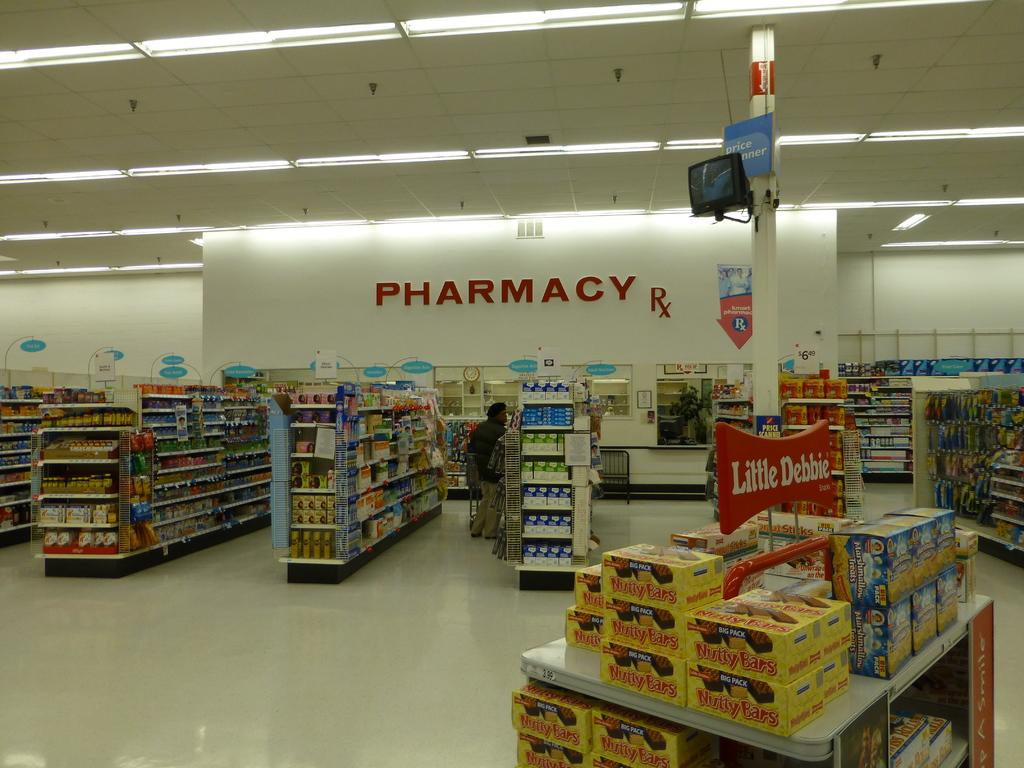<image>
Render a clear and concise summary of the photo. Grocery store that says pharmacy in the background. 